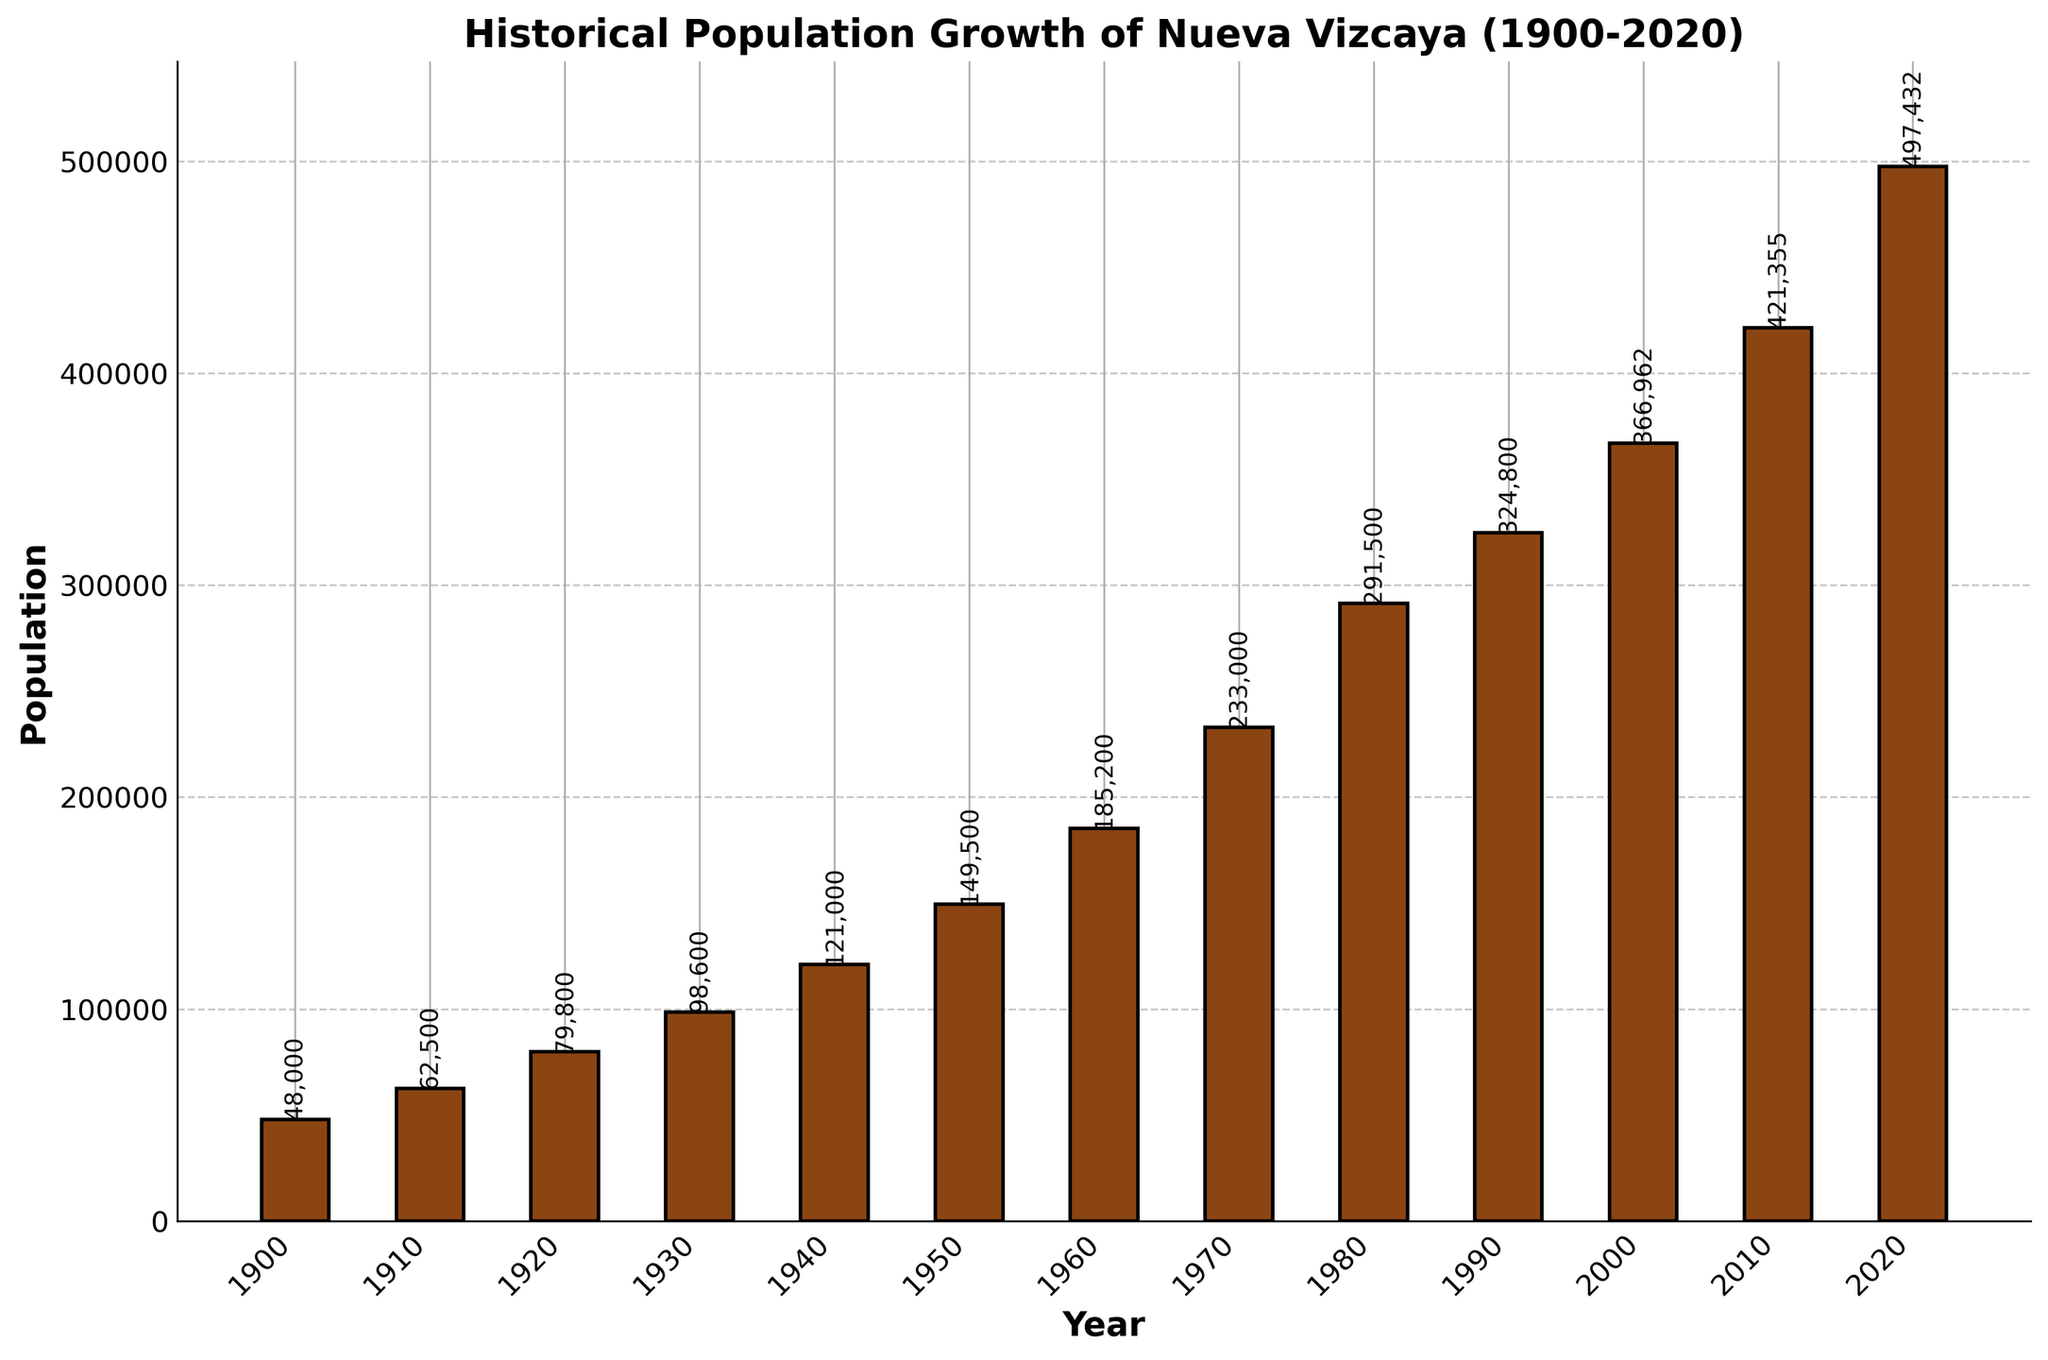When did the population of Nueva Vizcaya reach 300,000? Identify the year where the population value first exceeds 300,000 by inspecting the bar heights and their corresponding labels. The population first reaches 324,800 in 1990.
Answer: 1990 What was the population growth from 1900 to 1950? Subtract the population in the year 1900 from the population in 1950. The growth is 149,500 - 48,000.
Answer: 101,500 In which decade did Nueva Vizcaya see the highest population increase? Calculate the population increase for each decade by subtracting the previous decade's population from the current one. Identify the decade with the largest difference. The highest increase is from 2010 to 2020 (497,432 - 421,355).
Answer: 2010-2020 Which decade had the smallest population growth? Find the difference in population for each decade and identify the smallest one. The smallest difference is between 1990 and 2000 (366,962 - 324,800).
Answer: 1990-2000 How many times did the population double from 1900 to 2020? Starting with the population in 1900, determine how many times the population doubles (i.e., multiply by 2) until it reaches or exceeds 497,432. The population doubled less than three times (48,000 to 96,000, to 192,000, not reaching 384,000).
Answer: 2 In which decade did the population exceed 200,000? Identify the first decade where the population value surpasses 200,000 by inspecting the bar heights and their labels. The population exceeds 200,000 in 1970.
Answer: 1970 Compare the population growth of Nueva Vizcaya between 1960-1970 and 1980-1990. Which period saw greater growth? Calculate the population growth in each period by subtracting the earlier population from the later one. Compare (233,000 - 185,200) to (324,800 - 291,500). Growth from 1960 to 1970 is greater.
Answer: 1960-1970 What is the average population over the entire recorded period? Sum the population values for all the decades (48,000 + 62,500 + 79,800 + 98,600 + 121,000 + 149,500 + 185,200 + 233,000 + 291,500 + 324,800 + 366,962 + 421,355 + 497,432) and divide by the number of decades (13). The average is approximately 223,258.
Answer: 223,258 